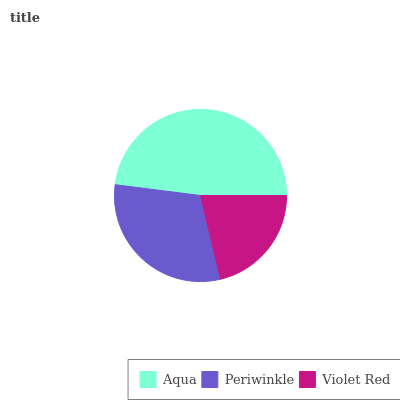Is Violet Red the minimum?
Answer yes or no. Yes. Is Aqua the maximum?
Answer yes or no. Yes. Is Periwinkle the minimum?
Answer yes or no. No. Is Periwinkle the maximum?
Answer yes or no. No. Is Aqua greater than Periwinkle?
Answer yes or no. Yes. Is Periwinkle less than Aqua?
Answer yes or no. Yes. Is Periwinkle greater than Aqua?
Answer yes or no. No. Is Aqua less than Periwinkle?
Answer yes or no. No. Is Periwinkle the high median?
Answer yes or no. Yes. Is Periwinkle the low median?
Answer yes or no. Yes. Is Violet Red the high median?
Answer yes or no. No. Is Aqua the low median?
Answer yes or no. No. 